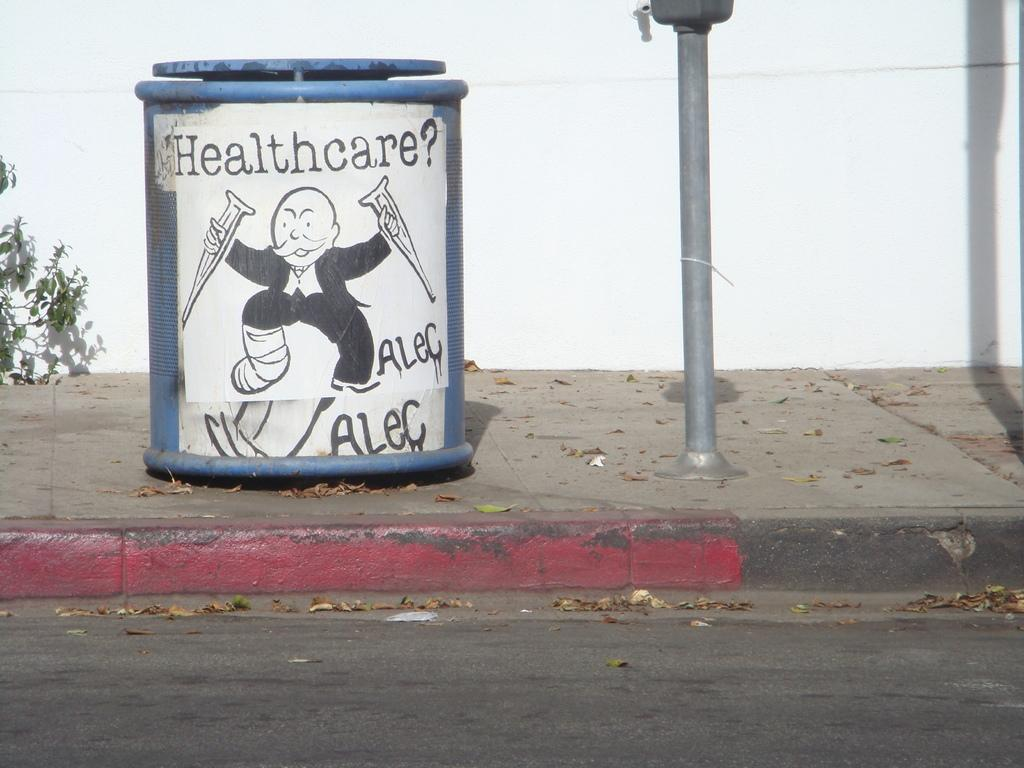<image>
Relay a brief, clear account of the picture shown. A blue container with Healthcare? on the front of the label. 